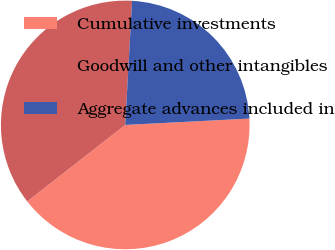Convert chart. <chart><loc_0><loc_0><loc_500><loc_500><pie_chart><fcel>Cumulative investments<fcel>Goodwill and other intangibles<fcel>Aggregate advances included in<nl><fcel>40.27%<fcel>36.42%<fcel>23.31%<nl></chart> 